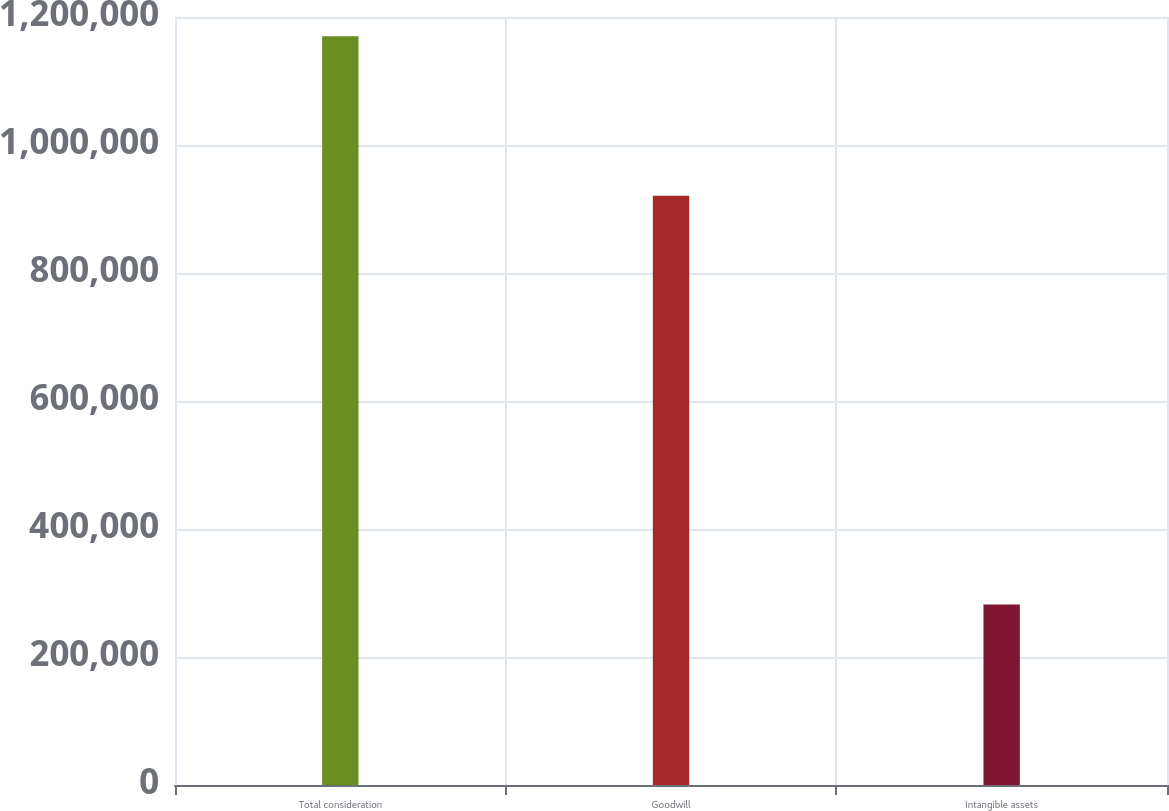<chart> <loc_0><loc_0><loc_500><loc_500><bar_chart><fcel>Total consideration<fcel>Goodwill<fcel>Intangible assets<nl><fcel>1.17004e+06<fcel>920696<fcel>282144<nl></chart> 